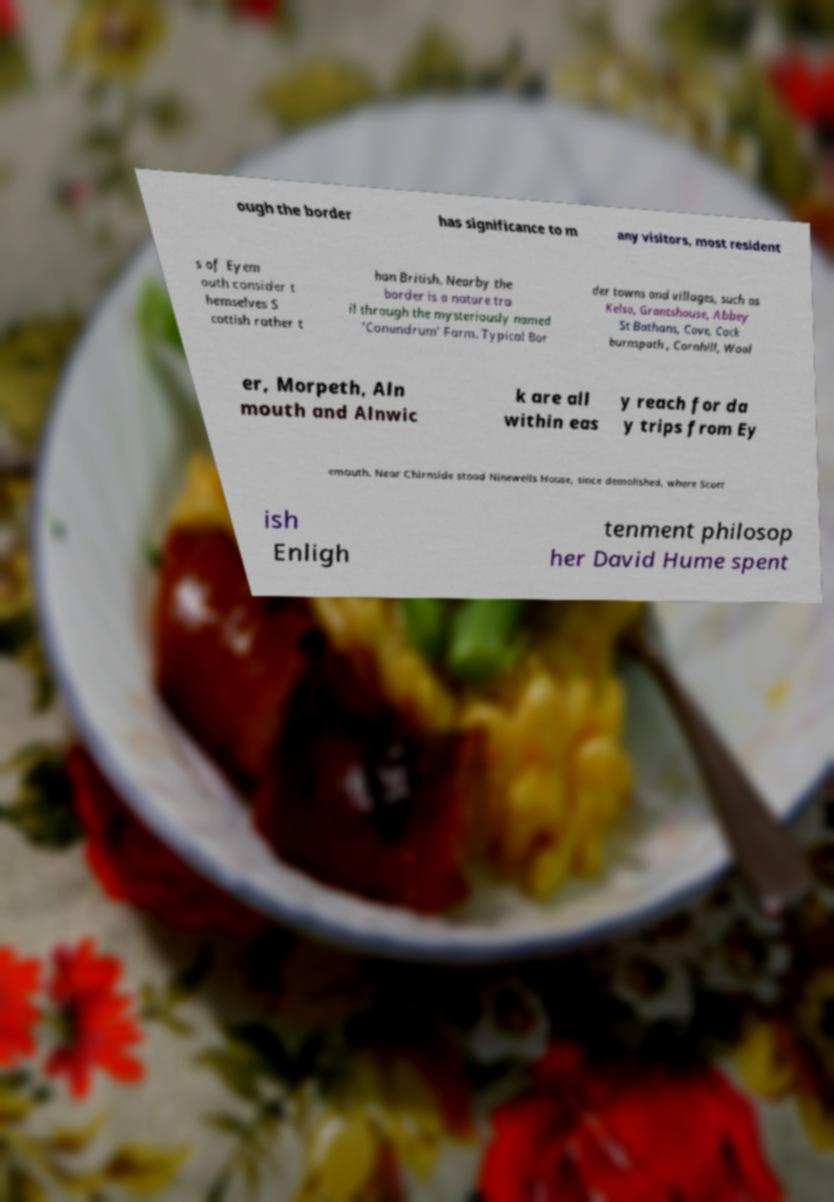Could you assist in decoding the text presented in this image and type it out clearly? ough the border has significance to m any visitors, most resident s of Eyem outh consider t hemselves S cottish rather t han British. Nearby the border is a nature tra il through the mysteriously named 'Conundrum' Farm. Typical Bor der towns and villages, such as Kelso, Grantshouse, Abbey St Bathans, Cove, Cock burnspath , Cornhill, Wool er, Morpeth, Aln mouth and Alnwic k are all within eas y reach for da y trips from Ey emouth. Near Chirnside stood Ninewells House, since demolished, where Scott ish Enligh tenment philosop her David Hume spent 